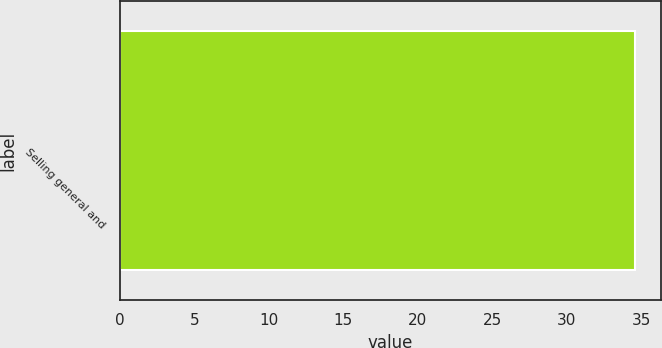Convert chart. <chart><loc_0><loc_0><loc_500><loc_500><bar_chart><fcel>Selling general and<nl><fcel>34.6<nl></chart> 